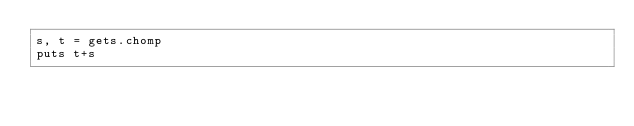Convert code to text. <code><loc_0><loc_0><loc_500><loc_500><_Ruby_>s, t = gets.chomp
puts t+s</code> 